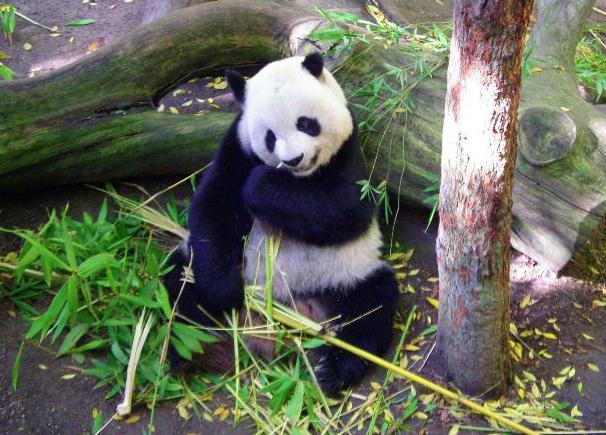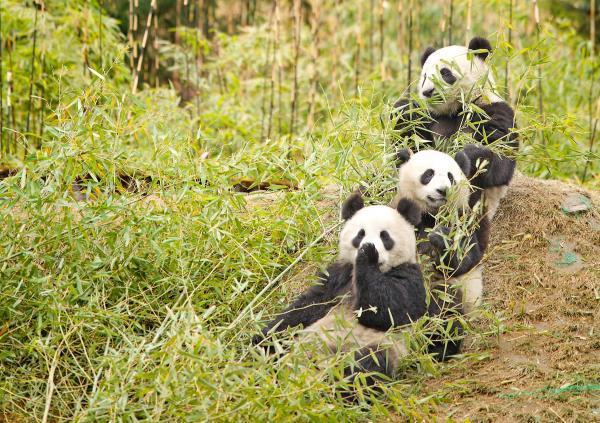The first image is the image on the left, the second image is the image on the right. Analyze the images presented: Is the assertion "there is a panda sitting on the ground in front of a fallen tree log with a standing tree trunk to the right of the panda" valid? Answer yes or no. Yes. The first image is the image on the left, the second image is the image on the right. Given the left and right images, does the statement "All pandas are grasping part of a bamboo plant, and at least one of the pandas depicted faces forward with his rightward elbow bent and paw raised to his mouth." hold true? Answer yes or no. Yes. 